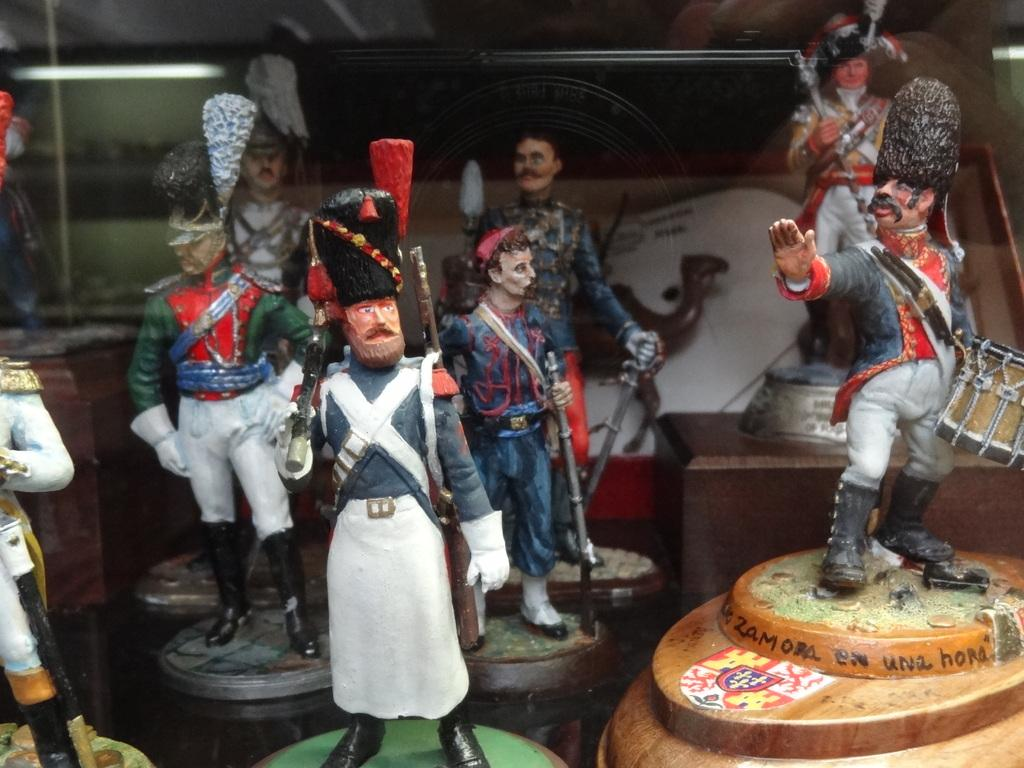What type of objects can be seen in the image? There are toys in the image. Can you describe any specific details about the toys? One of the toys has text on it. What type of sheet is covering the toys in the image? There is no sheet covering the toys in the image. 